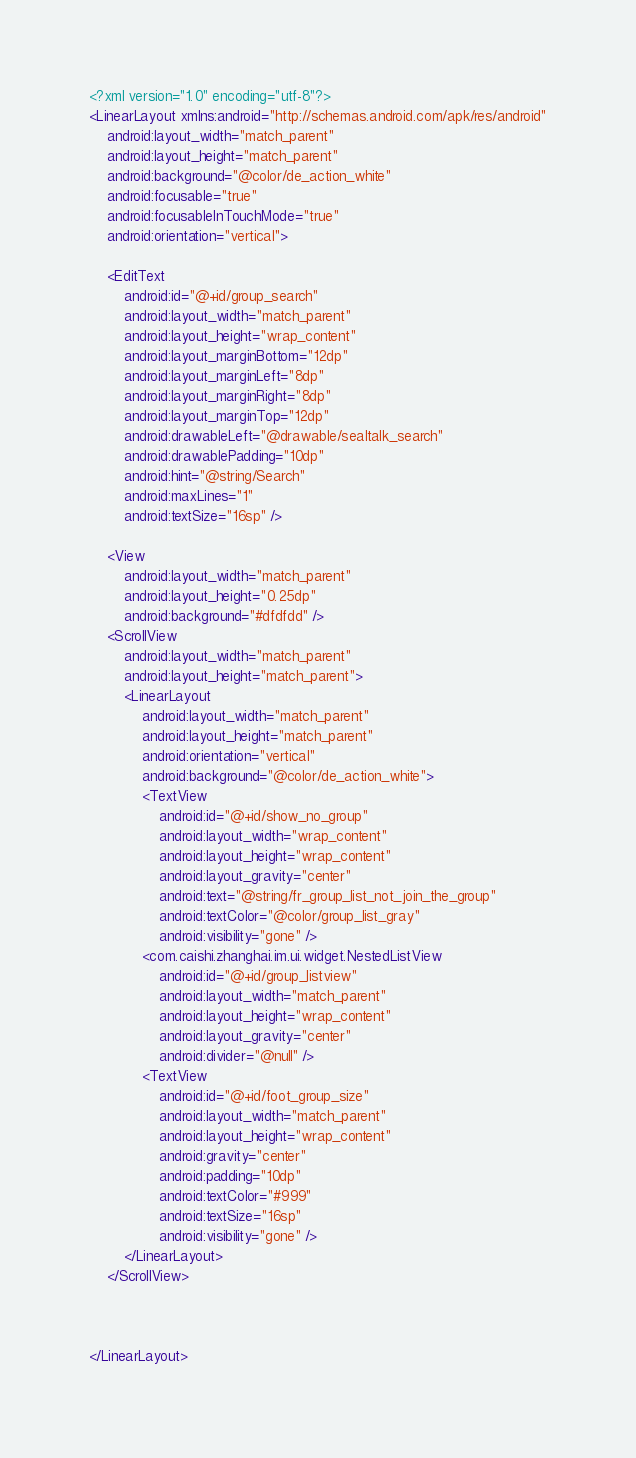<code> <loc_0><loc_0><loc_500><loc_500><_XML_><?xml version="1.0" encoding="utf-8"?>
<LinearLayout xmlns:android="http://schemas.android.com/apk/res/android"
    android:layout_width="match_parent"
    android:layout_height="match_parent"
    android:background="@color/de_action_white"
    android:focusable="true"
    android:focusableInTouchMode="true"
    android:orientation="vertical">

    <EditText
        android:id="@+id/group_search"
        android:layout_width="match_parent"
        android:layout_height="wrap_content"
        android:layout_marginBottom="12dp"
        android:layout_marginLeft="8dp"
        android:layout_marginRight="8dp"
        android:layout_marginTop="12dp"
        android:drawableLeft="@drawable/sealtalk_search"
        android:drawablePadding="10dp"
        android:hint="@string/Search"
        android:maxLines="1"
        android:textSize="16sp" />

    <View
        android:layout_width="match_parent"
        android:layout_height="0.25dp"
        android:background="#dfdfdd" />
    <ScrollView
        android:layout_width="match_parent"
        android:layout_height="match_parent">
        <LinearLayout
            android:layout_width="match_parent"
            android:layout_height="match_parent"
            android:orientation="vertical"
            android:background="@color/de_action_white">
            <TextView
                android:id="@+id/show_no_group"
                android:layout_width="wrap_content"
                android:layout_height="wrap_content"
                android:layout_gravity="center"
                android:text="@string/fr_group_list_not_join_the_group"
                android:textColor="@color/group_list_gray"
                android:visibility="gone" />
            <com.caishi.zhanghai.im.ui.widget.NestedListView
                android:id="@+id/group_listview"
                android:layout_width="match_parent"
                android:layout_height="wrap_content"
                android:layout_gravity="center"
                android:divider="@null" />
            <TextView
                android:id="@+id/foot_group_size"
                android:layout_width="match_parent"
                android:layout_height="wrap_content"
                android:gravity="center"
                android:padding="10dp"
                android:textColor="#999"
                android:textSize="16sp"
                android:visibility="gone" />
        </LinearLayout>
    </ScrollView>



</LinearLayout></code> 